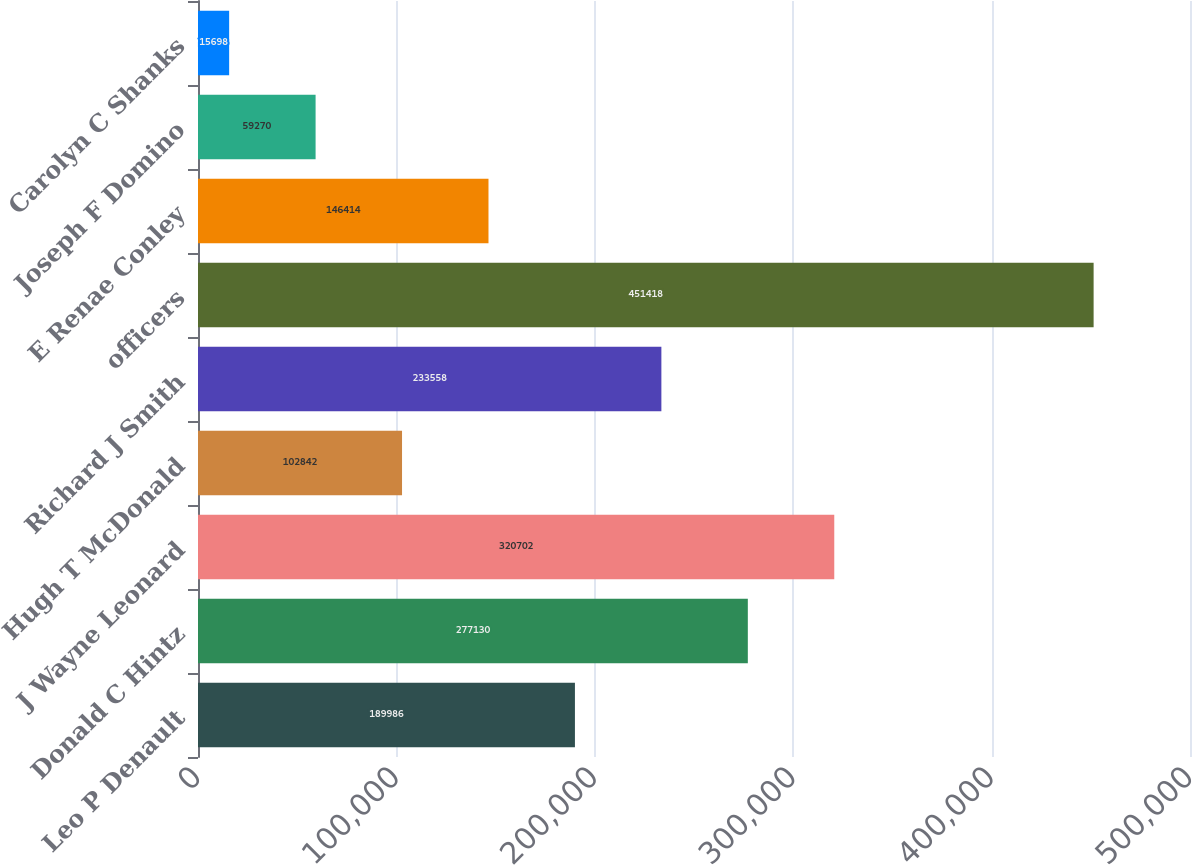<chart> <loc_0><loc_0><loc_500><loc_500><bar_chart><fcel>Leo P Denault<fcel>Donald C Hintz<fcel>J Wayne Leonard<fcel>Hugh T McDonald<fcel>Richard J Smith<fcel>officers<fcel>E Renae Conley<fcel>Joseph F Domino<fcel>Carolyn C Shanks<nl><fcel>189986<fcel>277130<fcel>320702<fcel>102842<fcel>233558<fcel>451418<fcel>146414<fcel>59270<fcel>15698<nl></chart> 